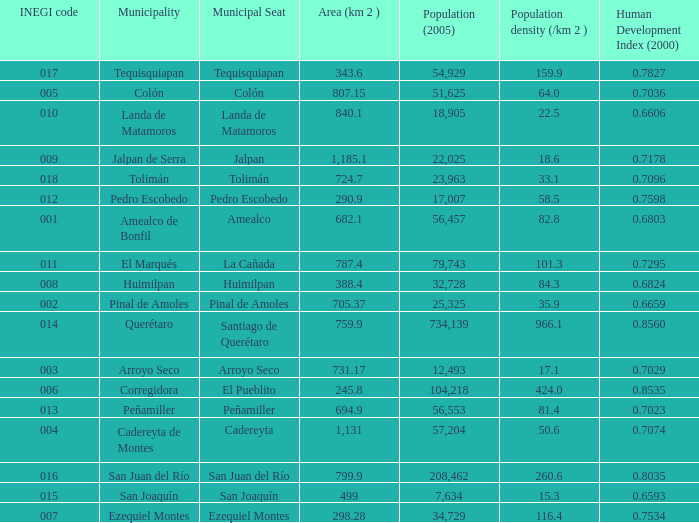WHat is the amount of Human Development Index (2000) that has a Population (2005) of 54,929, and an Area (km 2 ) larger than 343.6? 0.0. 